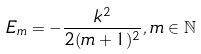Convert formula to latex. <formula><loc_0><loc_0><loc_500><loc_500>E _ { m } = - \frac { k ^ { 2 } } { 2 ( m + 1 ) ^ { 2 } } , m \in \mathbb { N }</formula> 